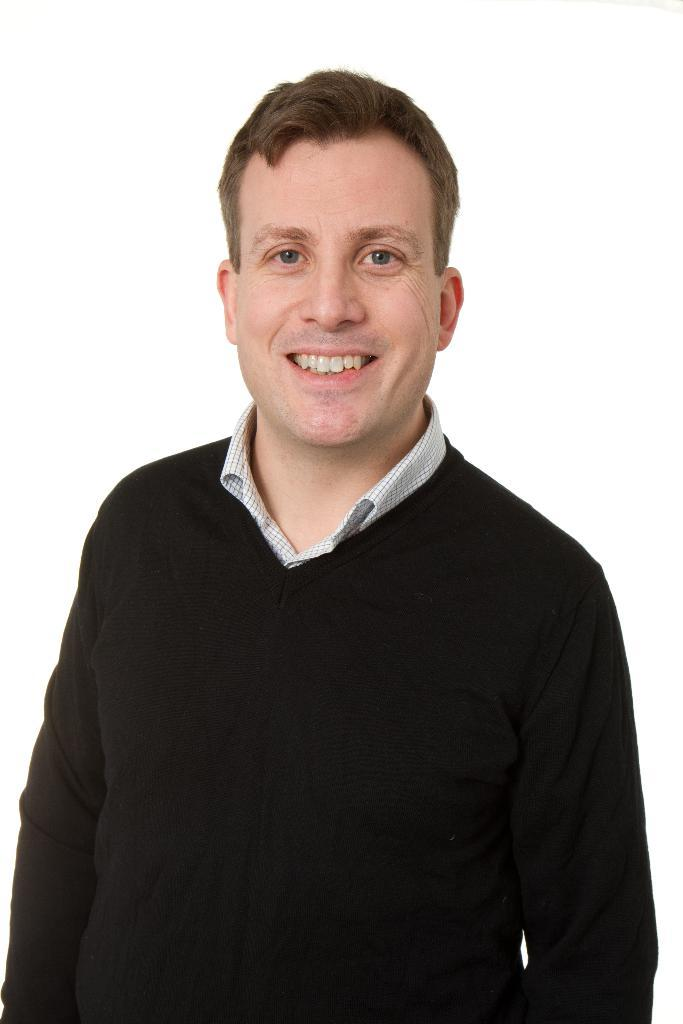Who is the main subject in the image? There is a person in the center of the image. What is the person wearing? The person is wearing a black dress. What is the person's facial expression? The person is smiling. How is the person positioned in the image? The person appears to be standing. What color is the background of the image? The background of the image is white in color. What song is the person singing in the image? There is no indication in the image that the person is singing, so it cannot be determined from the picture. 